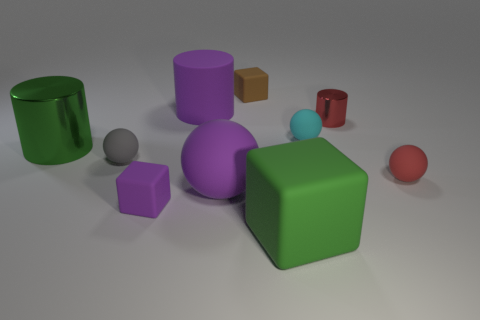Subtract all blocks. How many objects are left? 7 Add 5 red metal cylinders. How many red metal cylinders are left? 6 Add 5 large purple cubes. How many large purple cubes exist? 5 Subtract 0 blue cylinders. How many objects are left? 10 Subtract all small brown metallic cylinders. Subtract all tiny gray objects. How many objects are left? 9 